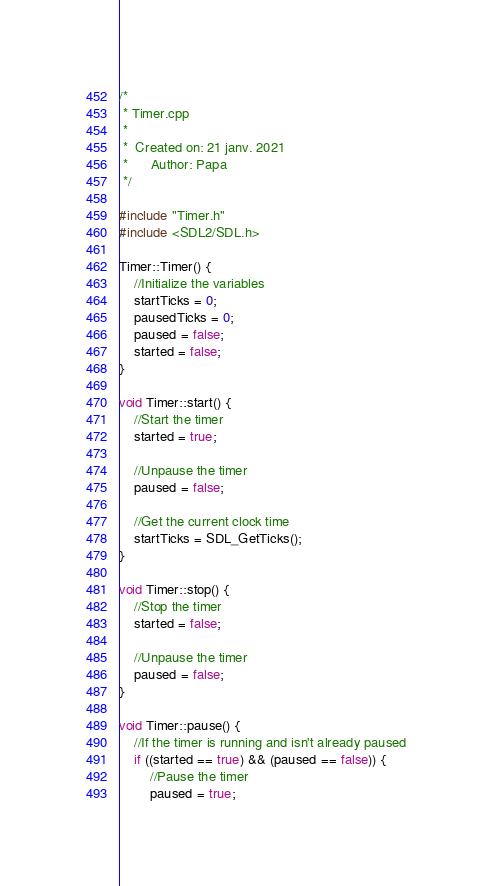<code> <loc_0><loc_0><loc_500><loc_500><_C++_>/*
 * Timer.cpp
 *
 *  Created on: 21 janv. 2021
 *      Author: Papa
 */

#include "Timer.h"
#include <SDL2/SDL.h>

Timer::Timer() {
	//Initialize the variables
	startTicks = 0;
	pausedTicks = 0;
	paused = false;
	started = false;
}

void Timer::start() {
	//Start the timer
	started = true;

	//Unpause the timer
	paused = false;

	//Get the current clock time
	startTicks = SDL_GetTicks();
}

void Timer::stop() {
	//Stop the timer
	started = false;

	//Unpause the timer
	paused = false;
}

void Timer::pause() {
	//If the timer is running and isn't already paused
	if ((started == true) && (paused == false)) {
		//Pause the timer
		paused = true;
</code> 